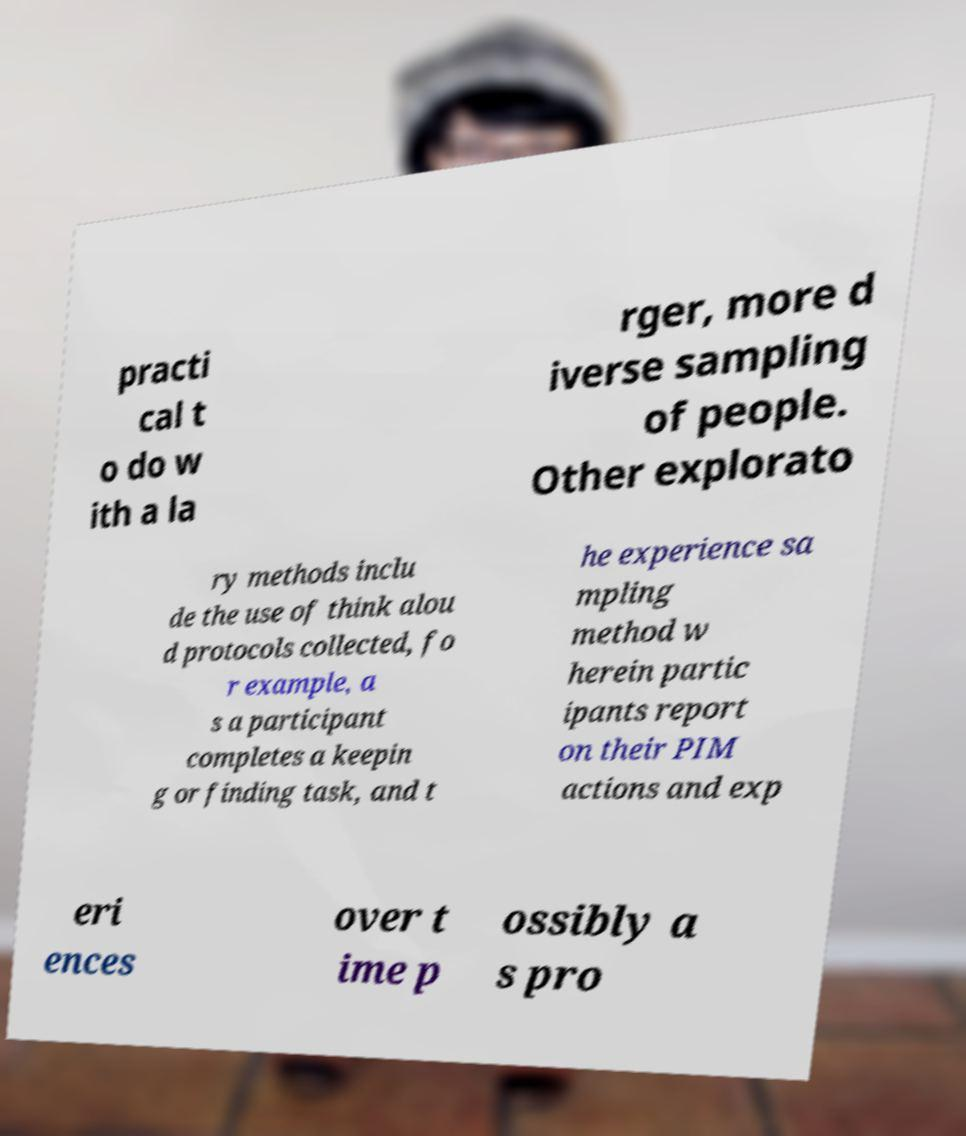Can you accurately transcribe the text from the provided image for me? practi cal t o do w ith a la rger, more d iverse sampling of people. Other explorato ry methods inclu de the use of think alou d protocols collected, fo r example, a s a participant completes a keepin g or finding task, and t he experience sa mpling method w herein partic ipants report on their PIM actions and exp eri ences over t ime p ossibly a s pro 